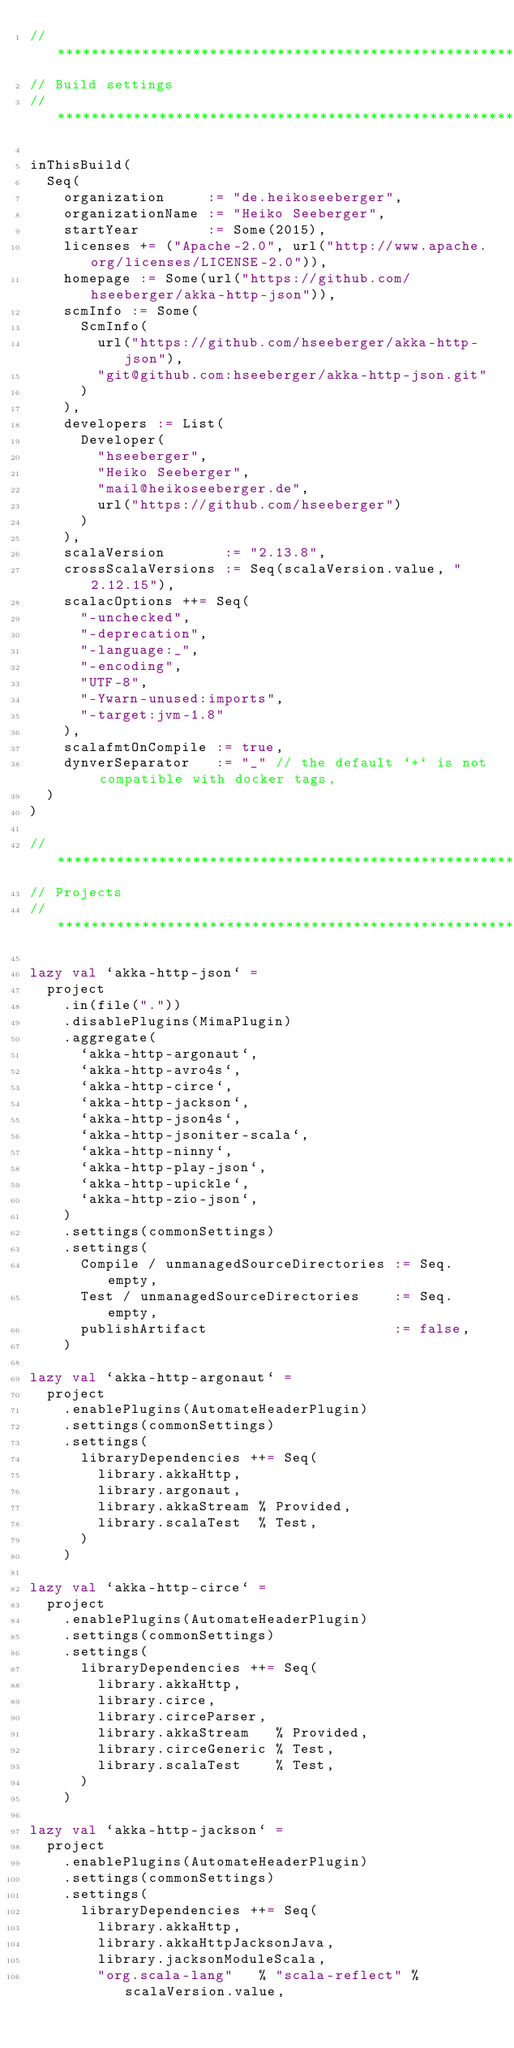Convert code to text. <code><loc_0><loc_0><loc_500><loc_500><_Scala_>// *****************************************************************************
// Build settings
// *****************************************************************************

inThisBuild(
  Seq(
    organization     := "de.heikoseeberger",
    organizationName := "Heiko Seeberger",
    startYear        := Some(2015),
    licenses += ("Apache-2.0", url("http://www.apache.org/licenses/LICENSE-2.0")),
    homepage := Some(url("https://github.com/hseeberger/akka-http-json")),
    scmInfo := Some(
      ScmInfo(
        url("https://github.com/hseeberger/akka-http-json"),
        "git@github.com:hseeberger/akka-http-json.git"
      )
    ),
    developers := List(
      Developer(
        "hseeberger",
        "Heiko Seeberger",
        "mail@heikoseeberger.de",
        url("https://github.com/hseeberger")
      )
    ),
    scalaVersion       := "2.13.8",
    crossScalaVersions := Seq(scalaVersion.value, "2.12.15"),
    scalacOptions ++= Seq(
      "-unchecked",
      "-deprecation",
      "-language:_",
      "-encoding",
      "UTF-8",
      "-Ywarn-unused:imports",
      "-target:jvm-1.8"
    ),
    scalafmtOnCompile := true,
    dynverSeparator   := "_" // the default `+` is not compatible with docker tags,
  )
)

// *****************************************************************************
// Projects
// *****************************************************************************

lazy val `akka-http-json` =
  project
    .in(file("."))
    .disablePlugins(MimaPlugin)
    .aggregate(
      `akka-http-argonaut`,
      `akka-http-avro4s`,
      `akka-http-circe`,
      `akka-http-jackson`,
      `akka-http-json4s`,
      `akka-http-jsoniter-scala`,
      `akka-http-ninny`,
      `akka-http-play-json`,
      `akka-http-upickle`,
      `akka-http-zio-json`,
    )
    .settings(commonSettings)
    .settings(
      Compile / unmanagedSourceDirectories := Seq.empty,
      Test / unmanagedSourceDirectories    := Seq.empty,
      publishArtifact                      := false,
    )

lazy val `akka-http-argonaut` =
  project
    .enablePlugins(AutomateHeaderPlugin)
    .settings(commonSettings)
    .settings(
      libraryDependencies ++= Seq(
        library.akkaHttp,
        library.argonaut,
        library.akkaStream % Provided,
        library.scalaTest  % Test,
      )
    )

lazy val `akka-http-circe` =
  project
    .enablePlugins(AutomateHeaderPlugin)
    .settings(commonSettings)
    .settings(
      libraryDependencies ++= Seq(
        library.akkaHttp,
        library.circe,
        library.circeParser,
        library.akkaStream   % Provided,
        library.circeGeneric % Test,
        library.scalaTest    % Test,
      )
    )

lazy val `akka-http-jackson` =
  project
    .enablePlugins(AutomateHeaderPlugin)
    .settings(commonSettings)
    .settings(
      libraryDependencies ++= Seq(
        library.akkaHttp,
        library.akkaHttpJacksonJava,
        library.jacksonModuleScala,
        "org.scala-lang"   % "scala-reflect" % scalaVersion.value,</code> 